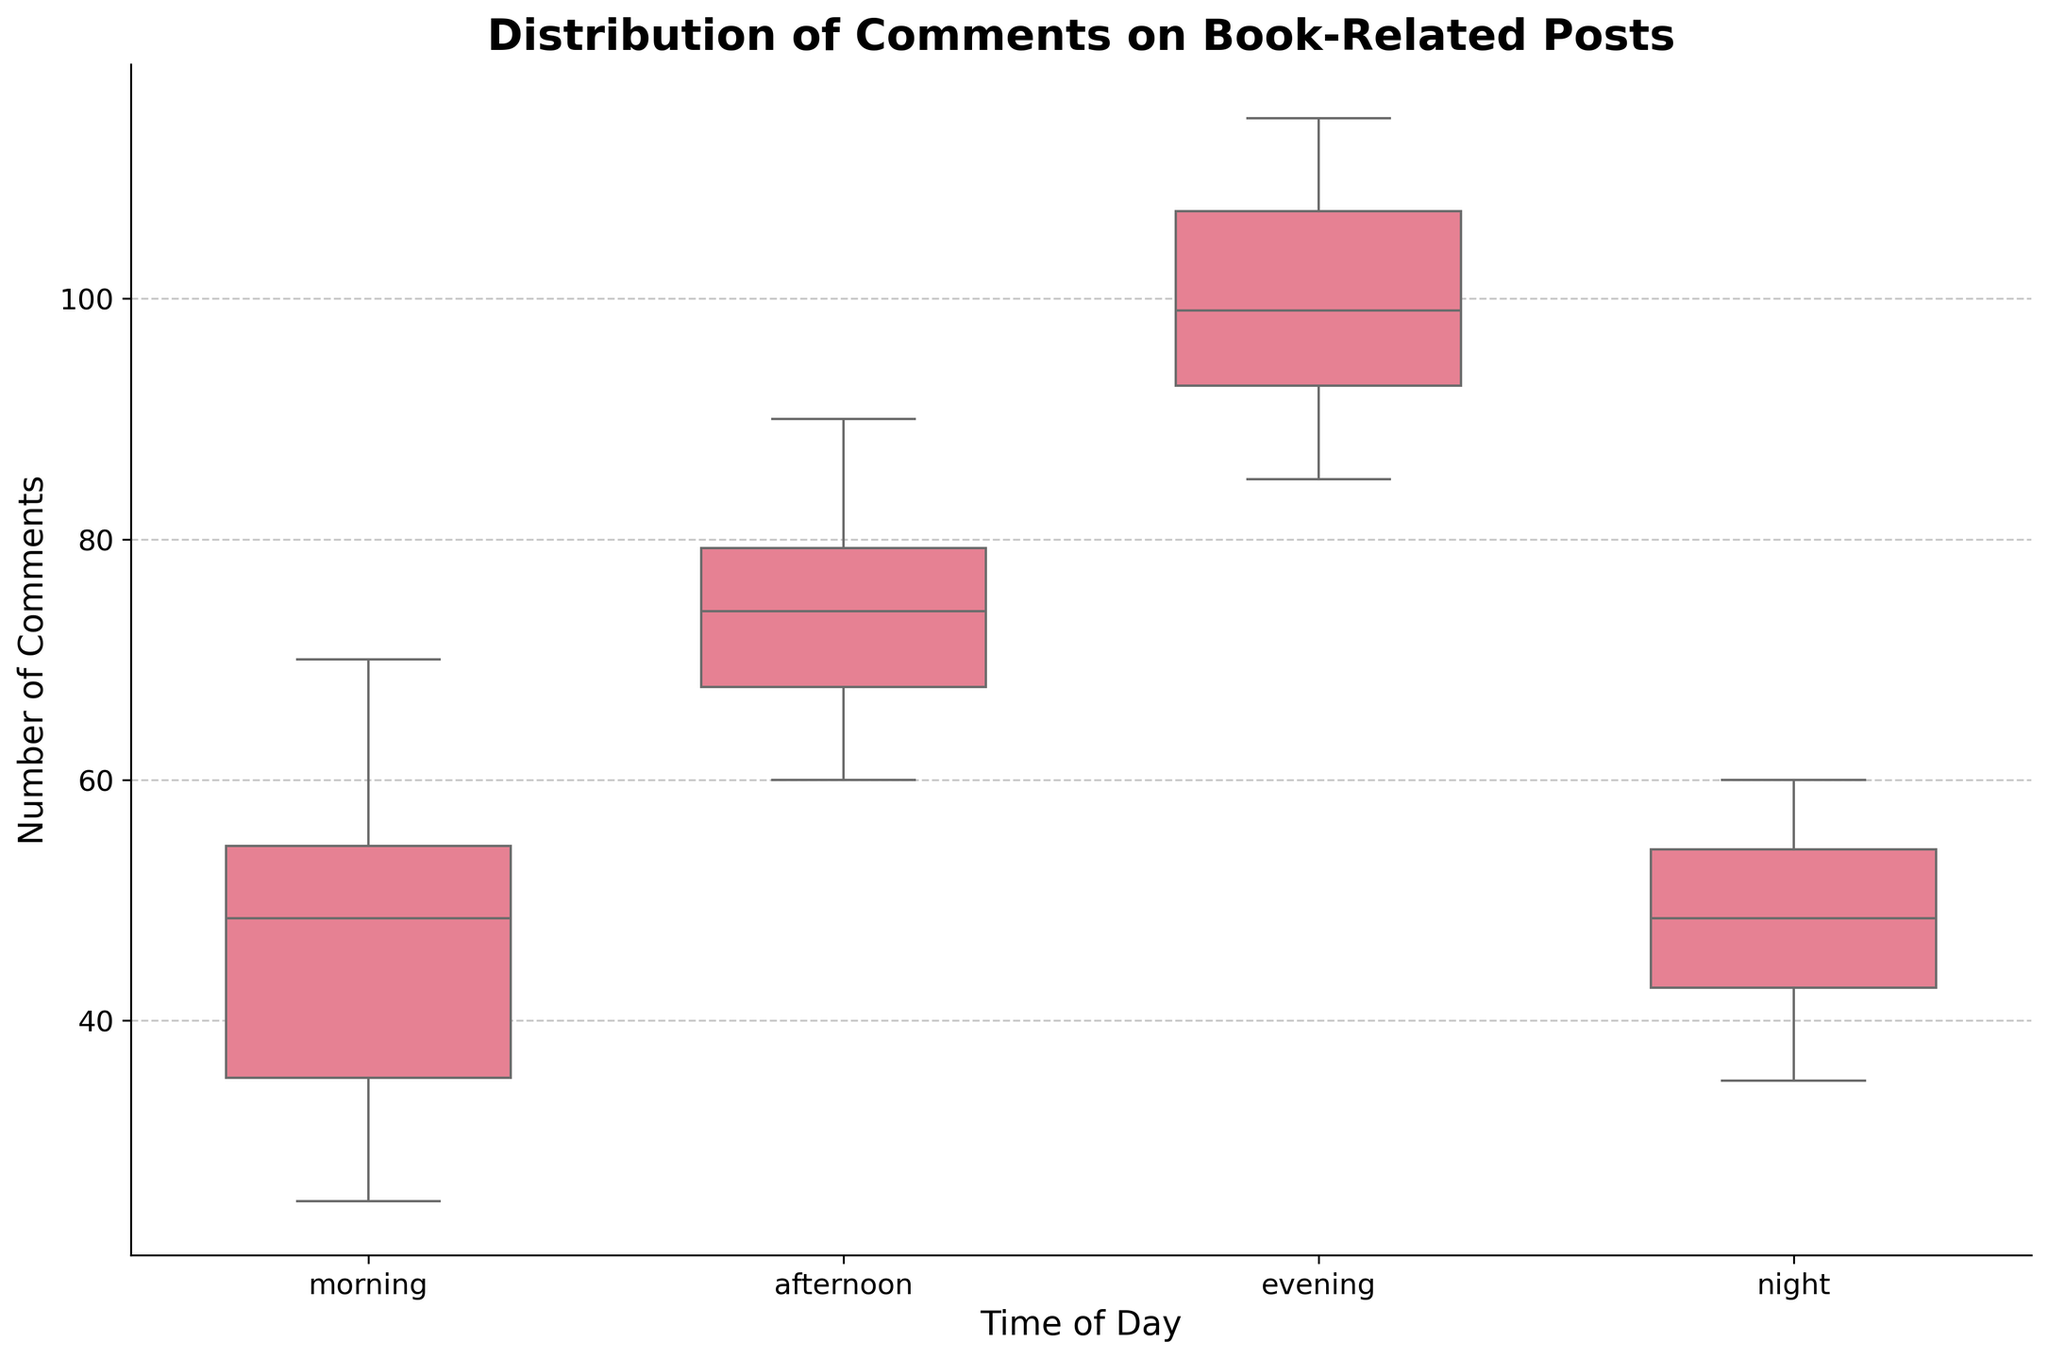What's the title of the figure? The title is visible at the top of the figure and it summarizes what the plot is about. The title says 'Distribution of Comments on Book-Related Posts,' indicating that the plot shows how comments on posts are distributed at different times of the day.
Answer: Distribution of Comments on Book-Related Posts What are the labels on the X and Y axes? The labels on the X and Y axes are clearly indicated in the figure. The X-axis is labeled 'Time of Day,' and the Y-axis is labeled 'Number of Comments.'
Answer: Time of Day, Number of Comments What time of day generally has the highest number of comments? To find the time of day with the highest number of comments, we look at the median lines in the boxplots for each time period. The evening boxplot has the highest median, indicating that it generally has the highest number of comments.
Answer: evening Which time of day shows the widest range of comments? The range is determined by the distance between the upper and lower whiskers in the box plots. The evening time period has the widest range as its whiskers spread out the most from the minimum to the maximum.
Answer: evening What is the median number of comments for afternoon posts? The median is indicated by the line inside the box of the boxplot. For the afternoon posts, this line shows the median number of comments is around 75.
Answer: 75 How does the number of comments in the morning compare to those at night? To compare the number of comments in the morning and at night, we can look at the medians of the box plots. The morning median is around 45, while the night median is slightly lower at around 47.
Answer: morning has a slightly higher but similar median Which time of day has the most consistent number of comments? Consistency can be identified by looking at the box length and the length of the whiskers. The morning boxplot is the smallest, indicating that comments are more consistent (less variation) during the morning.
Answer: morning Are there any outliers in the evening comments? Outliers typically appear as individual points outside the whiskers in a boxplot. The evening boxplot has a few individual points above the upper whisker, indicating there are outliers.
Answer: Yes In which time period do the comments have the least variation? Variation can be judged by the interquartile range (IQR), which is the length of the box in the boxplot. The smallest IQR is observed for the morning, indicating it has the least variation in comments.
Answer: morning 